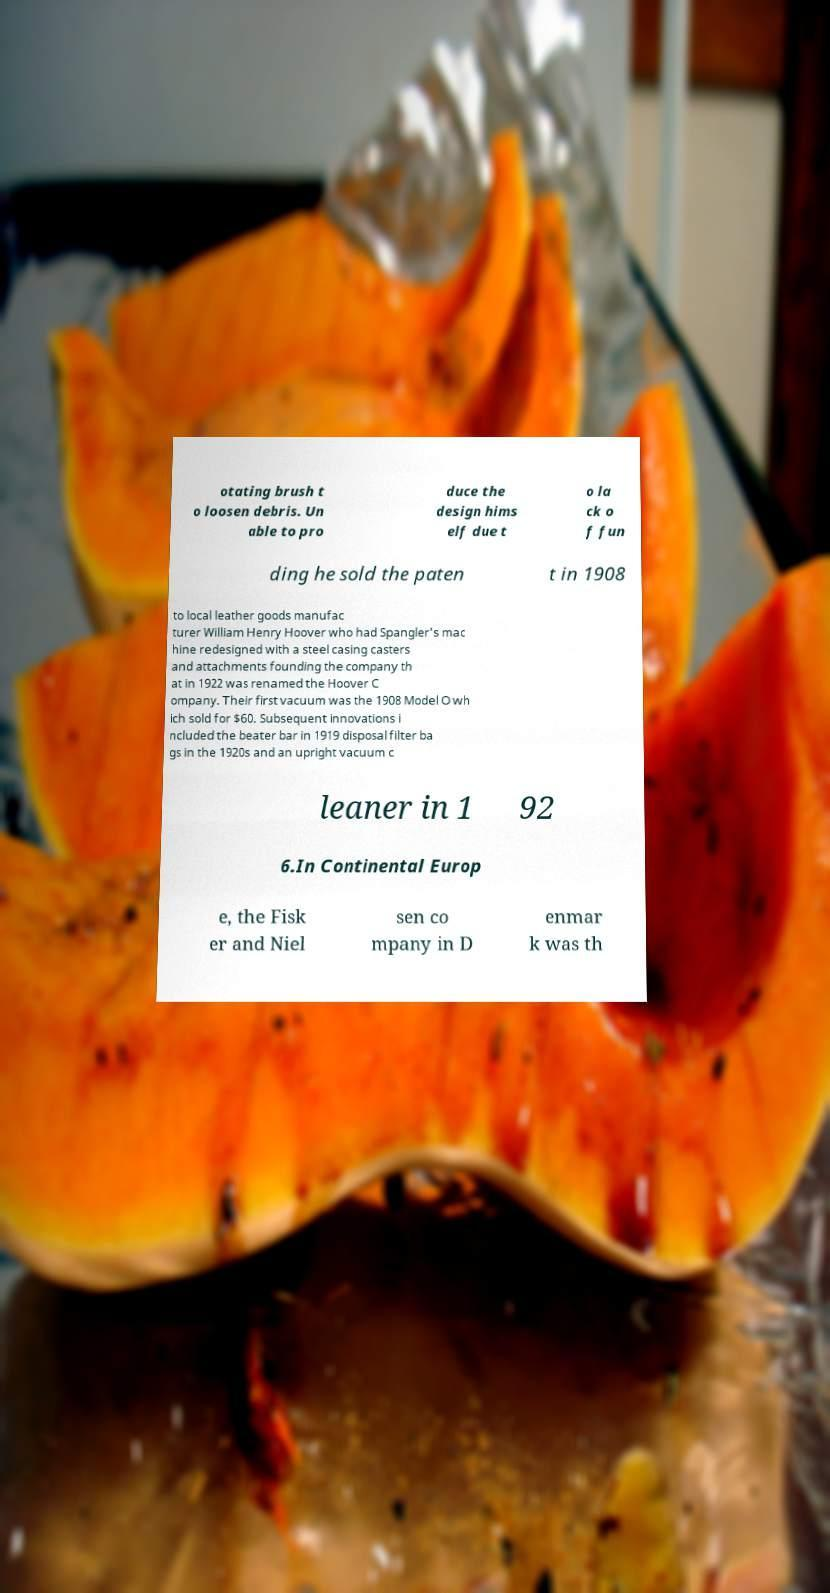What messages or text are displayed in this image? I need them in a readable, typed format. otating brush t o loosen debris. Un able to pro duce the design hims elf due t o la ck o f fun ding he sold the paten t in 1908 to local leather goods manufac turer William Henry Hoover who had Spangler's mac hine redesigned with a steel casing casters and attachments founding the company th at in 1922 was renamed the Hoover C ompany. Their first vacuum was the 1908 Model O wh ich sold for $60. Subsequent innovations i ncluded the beater bar in 1919 disposal filter ba gs in the 1920s and an upright vacuum c leaner in 1 92 6.In Continental Europ e, the Fisk er and Niel sen co mpany in D enmar k was th 